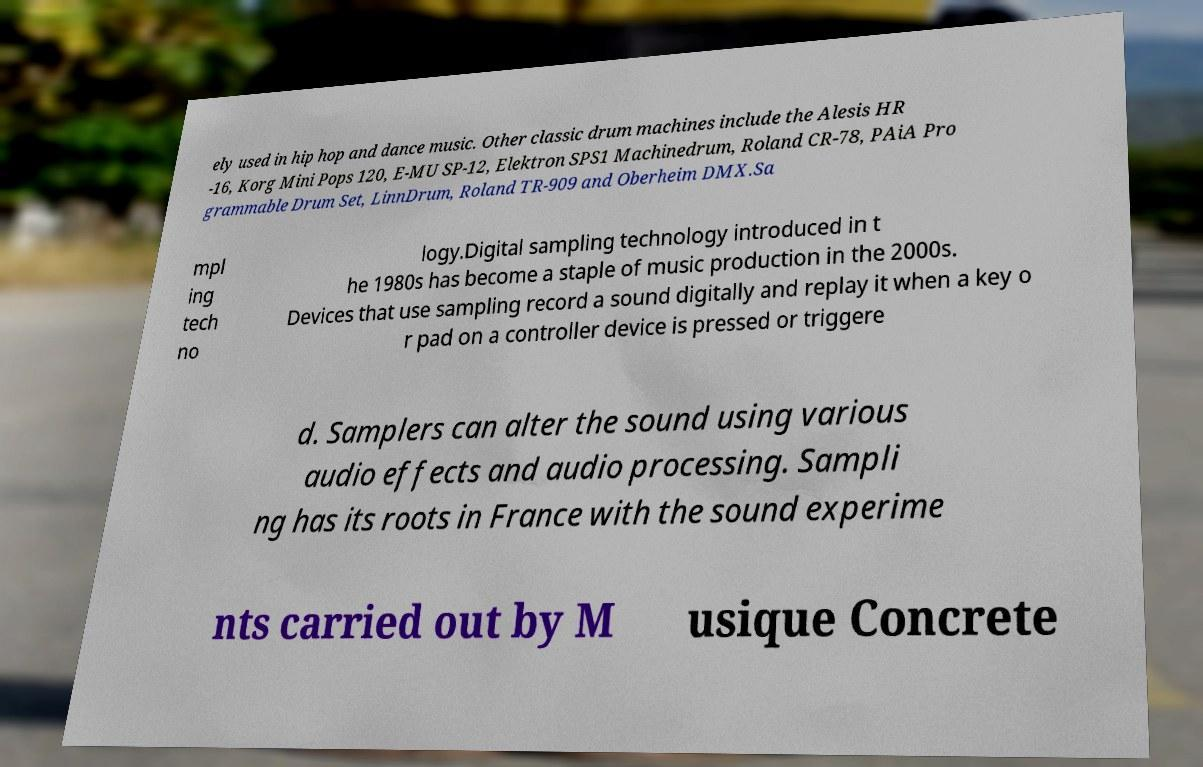What messages or text are displayed in this image? I need them in a readable, typed format. ely used in hip hop and dance music. Other classic drum machines include the Alesis HR -16, Korg Mini Pops 120, E-MU SP-12, Elektron SPS1 Machinedrum, Roland CR-78, PAiA Pro grammable Drum Set, LinnDrum, Roland TR-909 and Oberheim DMX.Sa mpl ing tech no logy.Digital sampling technology introduced in t he 1980s has become a staple of music production in the 2000s. Devices that use sampling record a sound digitally and replay it when a key o r pad on a controller device is pressed or triggere d. Samplers can alter the sound using various audio effects and audio processing. Sampli ng has its roots in France with the sound experime nts carried out by M usique Concrete 